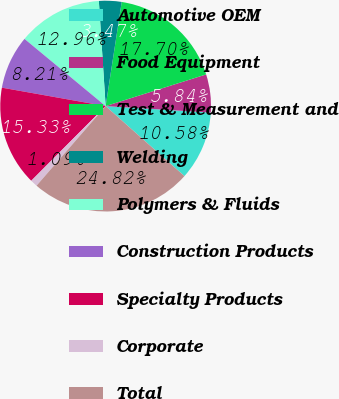Convert chart to OTSL. <chart><loc_0><loc_0><loc_500><loc_500><pie_chart><fcel>Automotive OEM<fcel>Food Equipment<fcel>Test & Measurement and<fcel>Welding<fcel>Polymers & Fluids<fcel>Construction Products<fcel>Specialty Products<fcel>Corporate<fcel>Total<nl><fcel>10.58%<fcel>5.84%<fcel>17.7%<fcel>3.47%<fcel>12.96%<fcel>8.21%<fcel>15.33%<fcel>1.09%<fcel>24.82%<nl></chart> 